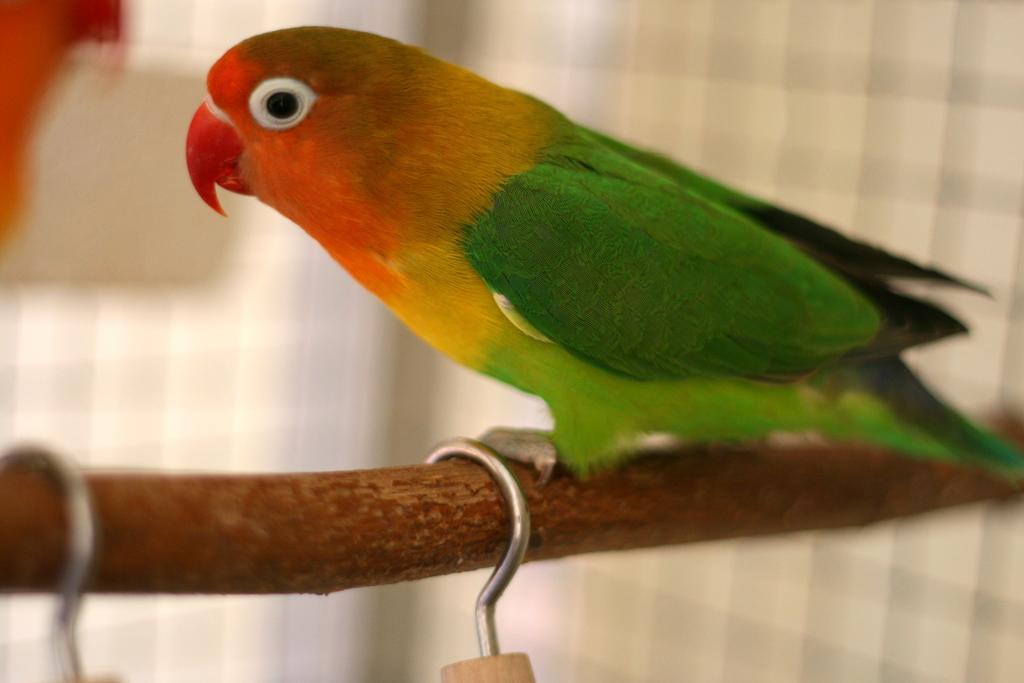Can you describe this image briefly? In this image we can see the parrot on the small wooden log. Here we can see the hooks. 